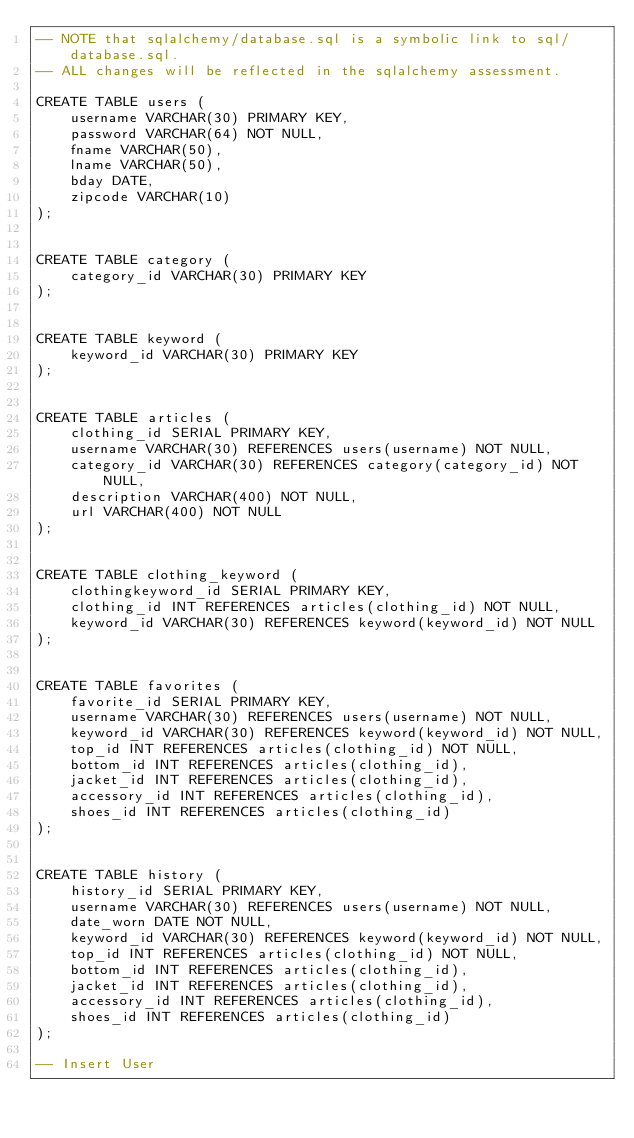<code> <loc_0><loc_0><loc_500><loc_500><_SQL_>-- NOTE that sqlalchemy/database.sql is a symbolic link to sql/database.sql. 
-- ALL changes will be reflected in the sqlalchemy assessment.

CREATE TABLE users (
    username VARCHAR(30) PRIMARY KEY,
    password VARCHAR(64) NOT NULL,
    fname VARCHAR(50),
    lname VARCHAR(50),
    bday DATE,
    zipcode VARCHAR(10)
);


CREATE TABLE category (
    category_id VARCHAR(30) PRIMARY KEY
);


CREATE TABLE keyword (
    keyword_id VARCHAR(30) PRIMARY KEY
);


CREATE TABLE articles (
    clothing_id SERIAL PRIMARY KEY,
    username VARCHAR(30) REFERENCES users(username) NOT NULL,
    category_id VARCHAR(30) REFERENCES category(category_id) NOT NULL,
    description VARCHAR(400) NOT NULL,
    url VARCHAR(400) NOT NULL
);


CREATE TABLE clothing_keyword (
    clothingkeyword_id SERIAL PRIMARY KEY,
    clothing_id INT REFERENCES articles(clothing_id) NOT NULL,
    keyword_id VARCHAR(30) REFERENCES keyword(keyword_id) NOT NULL
);


CREATE TABLE favorites (
    favorite_id SERIAL PRIMARY KEY,
    username VARCHAR(30) REFERENCES users(username) NOT NULL,
    keyword_id VARCHAR(30) REFERENCES keyword(keyword_id) NOT NULL,
    top_id INT REFERENCES articles(clothing_id) NOT NULL,
    bottom_id INT REFERENCES articles(clothing_id), 
    jacket_id INT REFERENCES articles(clothing_id),
    accessory_id INT REFERENCES articles(clothing_id),
    shoes_id INT REFERENCES articles(clothing_id)
);


CREATE TABLE history (
    history_id SERIAL PRIMARY KEY,
    username VARCHAR(30) REFERENCES users(username) NOT NULL,
    date_worn DATE NOT NULL,
    keyword_id VARCHAR(30) REFERENCES keyword(keyword_id) NOT NULL,
    top_id INT REFERENCES articles(clothing_id) NOT NULL,
    bottom_id INT REFERENCES articles(clothing_id), 
    jacket_id INT REFERENCES articles(clothing_id),
    accessory_id INT REFERENCES articles(clothing_id),
    shoes_id INT REFERENCES articles(clothing_id)
);

-- Insert User
</code> 